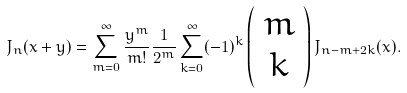<formula> <loc_0><loc_0><loc_500><loc_500>J _ { n } ( x + y ) = \sum _ { m = 0 } ^ { \infty } \frac { y ^ { m } } { m ! } \frac { 1 } { 2 ^ { m } } \sum _ { k = 0 } ^ { \infty } ( - 1 ) ^ { k } \left ( \begin{array} { c } m \\ k \end{array} \right ) J _ { n - m + 2 k } ( x ) .</formula> 